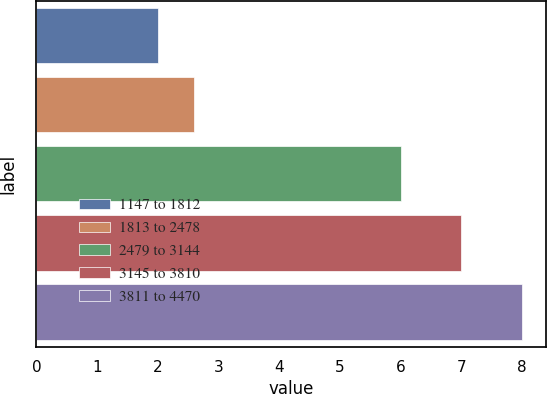<chart> <loc_0><loc_0><loc_500><loc_500><bar_chart><fcel>1147 to 1812<fcel>1813 to 2478<fcel>2479 to 3144<fcel>3145 to 3810<fcel>3811 to 4470<nl><fcel>2<fcel>2.6<fcel>6<fcel>7<fcel>8<nl></chart> 